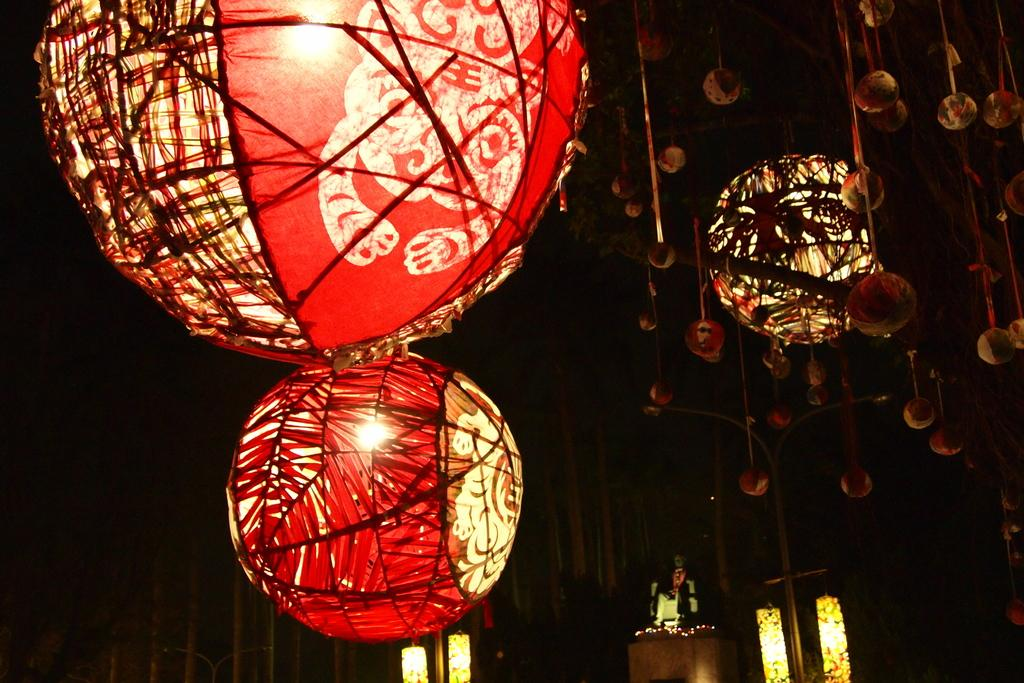What type of decorations are present in the image? There are many paper lanterns in the image. What is located at the bottom of the image? There is a table at the bottom of the image. What can be seen beside the table? There are lights beside the table. What is behind the table in the image? There is a wall behind the table. What is the size of the magic ground in the image? There is no mention of magic or a magic ground in the image; it only features paper lanterns, a table, lights, and a wall. 